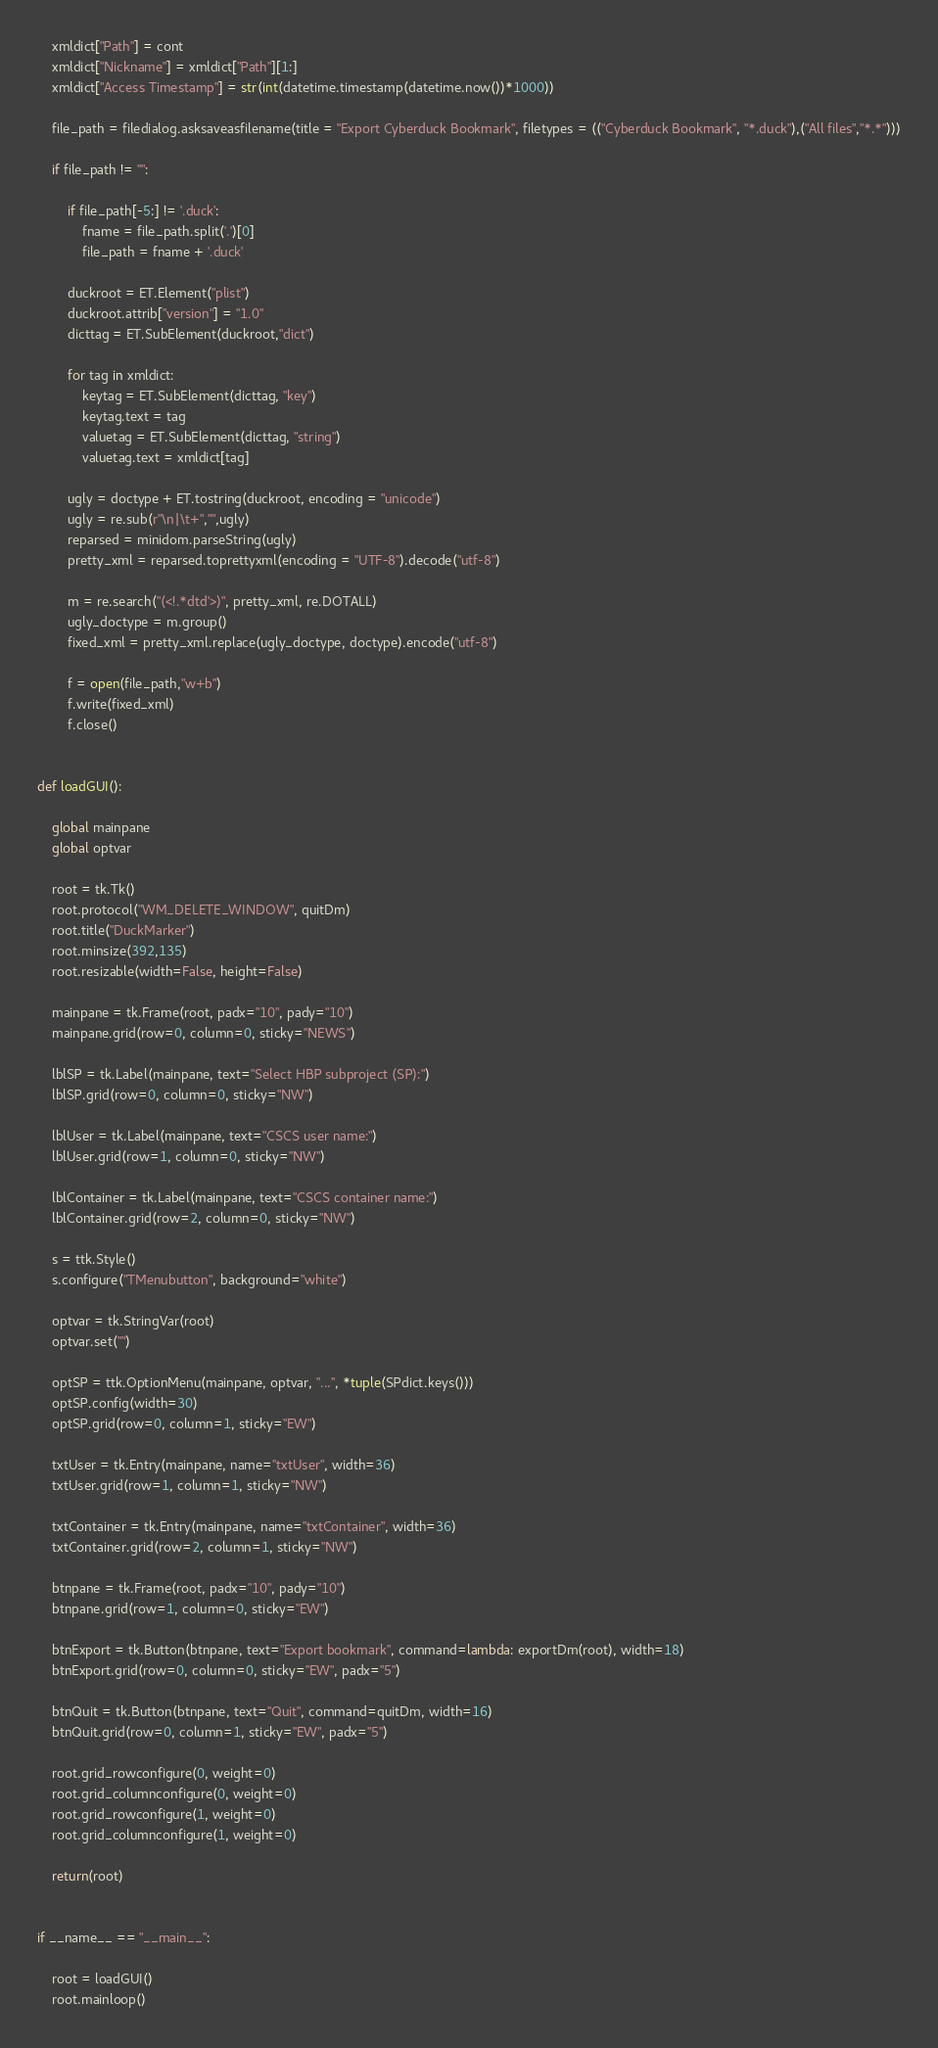Convert code to text. <code><loc_0><loc_0><loc_500><loc_500><_Python_>    xmldict["Path"] = cont
    xmldict["Nickname"] = xmldict["Path"][1:]
    xmldict["Access Timestamp"] = str(int(datetime.timestamp(datetime.now())*1000))

    file_path = filedialog.asksaveasfilename(title = "Export Cyberduck Bookmark", filetypes = (("Cyberduck Bookmark", "*.duck"),("All files","*.*")))

    if file_path != "":     

        if file_path[-5:] != '.duck':
            fname = file_path.split('.')[0]
            file_path = fname + '.duck'

        duckroot = ET.Element("plist")
        duckroot.attrib["version"] = "1.0"
        dicttag = ET.SubElement(duckroot,"dict")

        for tag in xmldict:
            keytag = ET.SubElement(dicttag, "key")
            keytag.text = tag
            valuetag = ET.SubElement(dicttag, "string")
            valuetag.text = xmldict[tag]

        ugly = doctype + ET.tostring(duckroot, encoding = "unicode")
        ugly = re.sub(r"\n|\t+","",ugly)
        reparsed = minidom.parseString(ugly)
        pretty_xml = reparsed.toprettyxml(encoding = "UTF-8").decode("utf-8")

        m = re.search("(<!.*dtd'>)", pretty_xml, re.DOTALL)
        ugly_doctype = m.group() 
        fixed_xml = pretty_xml.replace(ugly_doctype, doctype).encode("utf-8")

        f = open(file_path,"w+b")
        f.write(fixed_xml)
        f.close()


def loadGUI():
    
    global mainpane
    global optvar

    root = tk.Tk()
    root.protocol("WM_DELETE_WINDOW", quitDm)
    root.title("DuckMarker")
    root.minsize(392,135)
    root.resizable(width=False, height=False)

    mainpane = tk.Frame(root, padx="10", pady="10")
    mainpane.grid(row=0, column=0, sticky="NEWS")

    lblSP = tk.Label(mainpane, text="Select HBP subproject (SP):")
    lblSP.grid(row=0, column=0, sticky="NW")

    lblUser = tk.Label(mainpane, text="CSCS user name:")
    lblUser.grid(row=1, column=0, sticky="NW")

    lblContainer = tk.Label(mainpane, text="CSCS container name:")
    lblContainer.grid(row=2, column=0, sticky="NW")

    s = ttk.Style()
    s.configure("TMenubutton", background="white")   

    optvar = tk.StringVar(root)
    optvar.set("")

    optSP = ttk.OptionMenu(mainpane, optvar, "...", *tuple(SPdict.keys()))
    optSP.config(width=30)
    optSP.grid(row=0, column=1, sticky="EW")
        
    txtUser = tk.Entry(mainpane, name="txtUser", width=36)
    txtUser.grid(row=1, column=1, sticky="NW")

    txtContainer = tk.Entry(mainpane, name="txtContainer", width=36)
    txtContainer.grid(row=2, column=1, sticky="NW")    

    btnpane = tk.Frame(root, padx="10", pady="10")
    btnpane.grid(row=1, column=0, sticky="EW")

    btnExport = tk.Button(btnpane, text="Export bookmark", command=lambda: exportDm(root), width=18)
    btnExport.grid(row=0, column=0, sticky="EW", padx="5")

    btnQuit = tk.Button(btnpane, text="Quit", command=quitDm, width=16)
    btnQuit.grid(row=0, column=1, sticky="EW", padx="5")

    root.grid_rowconfigure(0, weight=0)
    root.grid_columnconfigure(0, weight=0)
    root.grid_rowconfigure(1, weight=0)
    root.grid_columnconfigure(1, weight=0)
    
    return(root)


if __name__ == "__main__":

    root = loadGUI()
    root.mainloop()    
</code> 